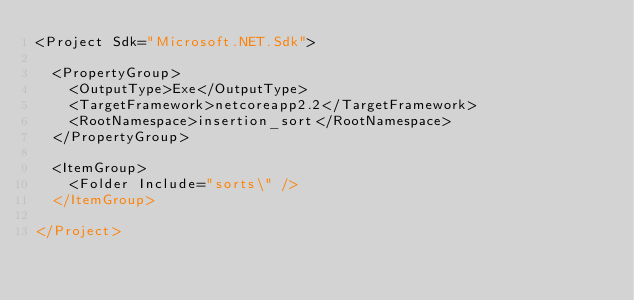<code> <loc_0><loc_0><loc_500><loc_500><_XML_><Project Sdk="Microsoft.NET.Sdk">

  <PropertyGroup>
    <OutputType>Exe</OutputType>
    <TargetFramework>netcoreapp2.2</TargetFramework>
    <RootNamespace>insertion_sort</RootNamespace>
  </PropertyGroup>

  <ItemGroup>
    <Folder Include="sorts\" />
  </ItemGroup>

</Project>
</code> 